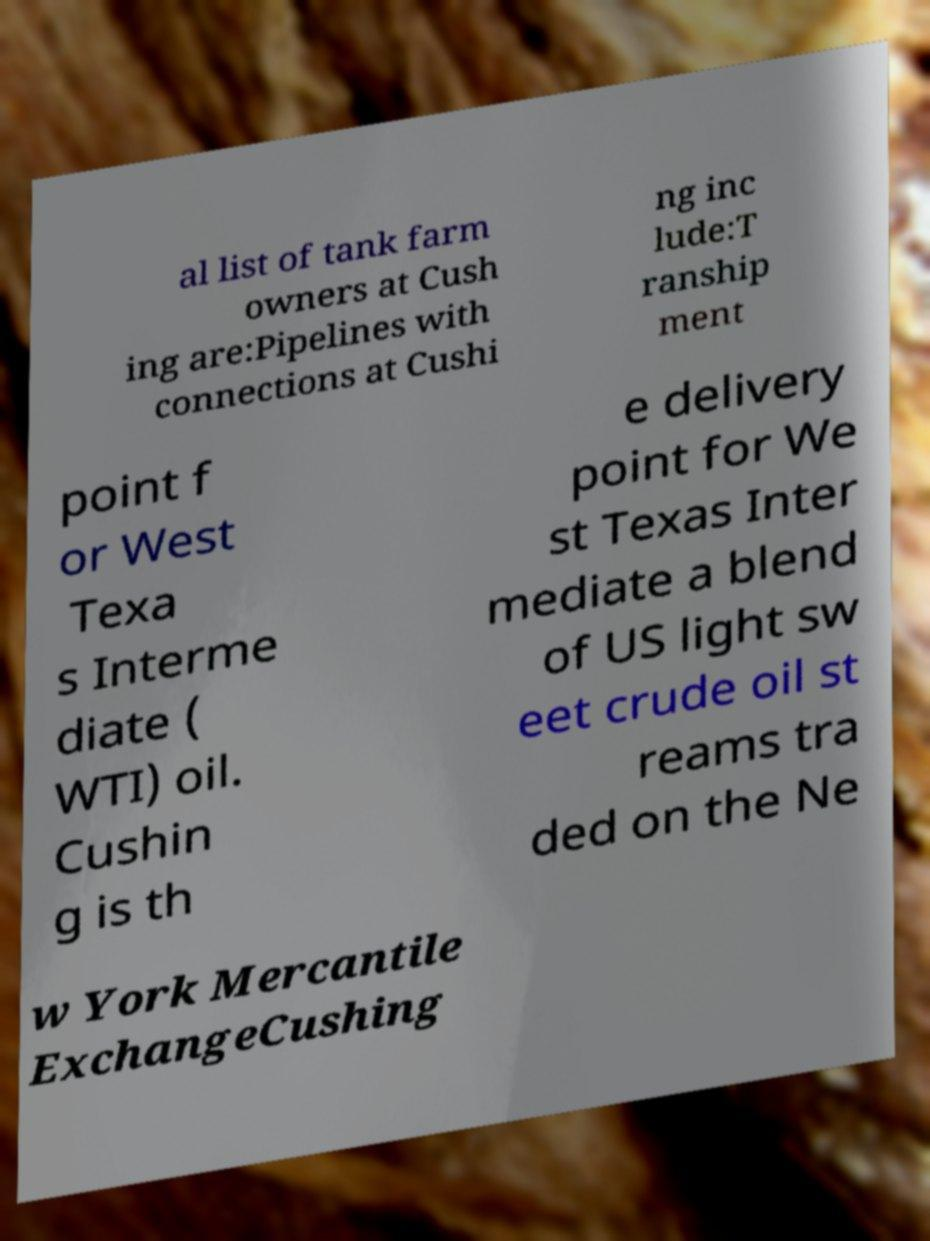Can you accurately transcribe the text from the provided image for me? al list of tank farm owners at Cush ing are:Pipelines with connections at Cushi ng inc lude:T ranship ment point f or West Texa s Interme diate ( WTI) oil. Cushin g is th e delivery point for We st Texas Inter mediate a blend of US light sw eet crude oil st reams tra ded on the Ne w York Mercantile ExchangeCushing 